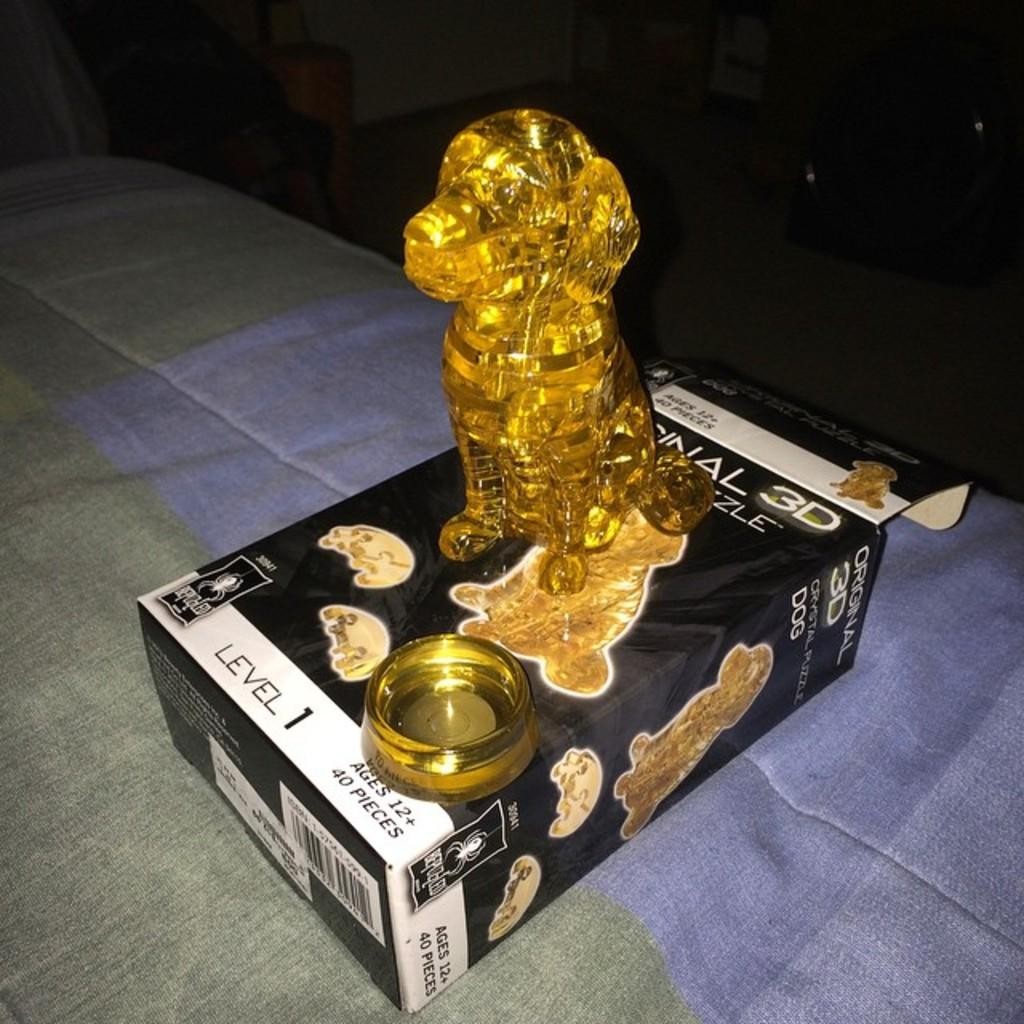What is the main subject of the image? The main subject of the image is a structure of a dog. What material is the dog structure made of? The structure is made of cardboard. Where is the cardboard dog structure located? The cardboard dog structure is on a bed. How does the bird in the image provide information? There is no bird present in the image, and the image does not depict any assistance or information being provided. 